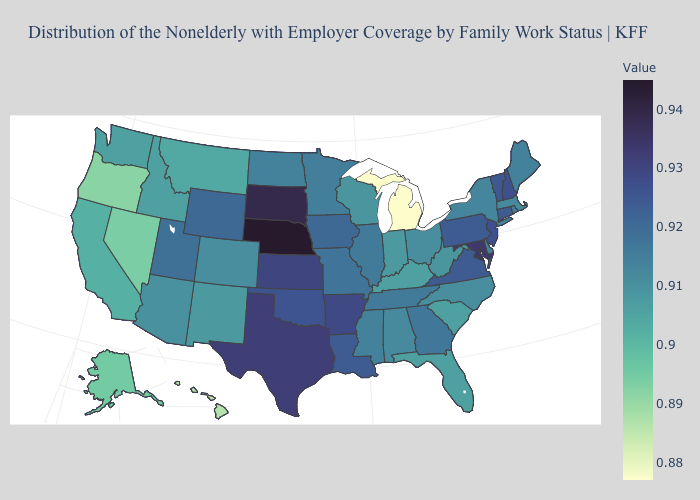Does South Carolina have a lower value than Michigan?
Quick response, please. No. Does Massachusetts have the lowest value in the Northeast?
Be succinct. Yes. Which states have the lowest value in the USA?
Concise answer only. Michigan. Which states have the lowest value in the USA?
Answer briefly. Michigan. Which states have the lowest value in the West?
Be succinct. Hawaii. 